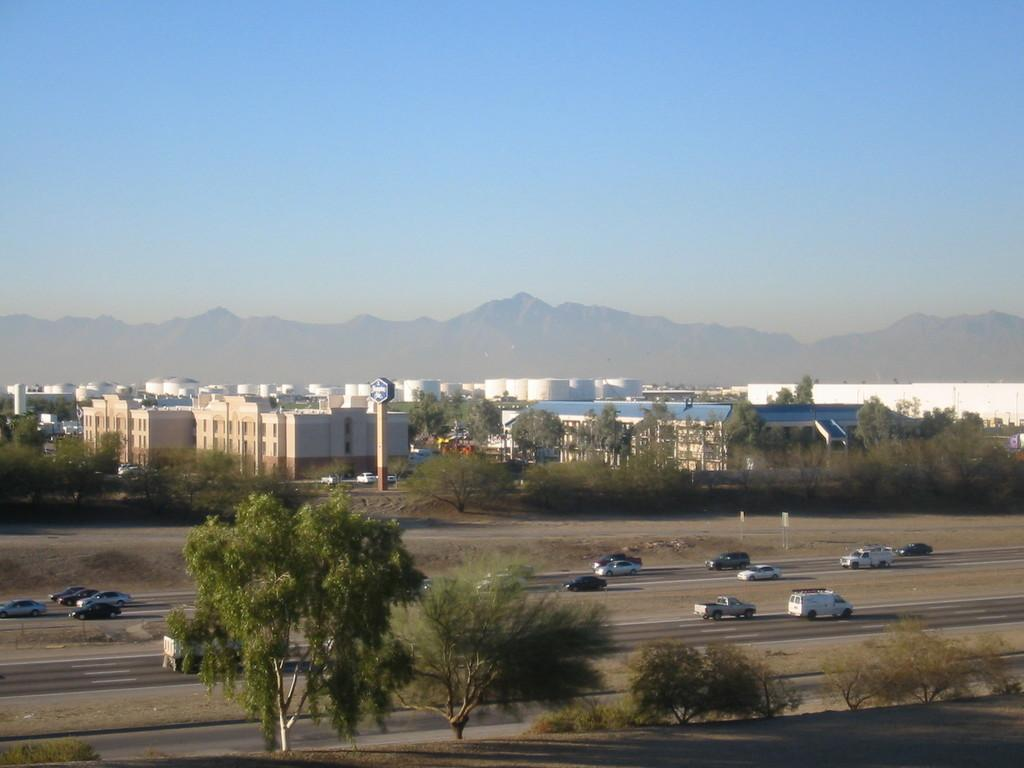What type of natural elements can be seen in the image? There are trees and hills visible in the image. What is happening on the road in the image? Vehicles are moving on the road in the image. Can you describe the board in the image? There is a board attached to a pole in the image. What type of structures are present in the image? There are buildings in the image. What is the color of the sky in the background of the image? The sky in the background of the image is blue. What type of bean is being advertised on the board in the image? There is no bean advertisement on the board in the image. 